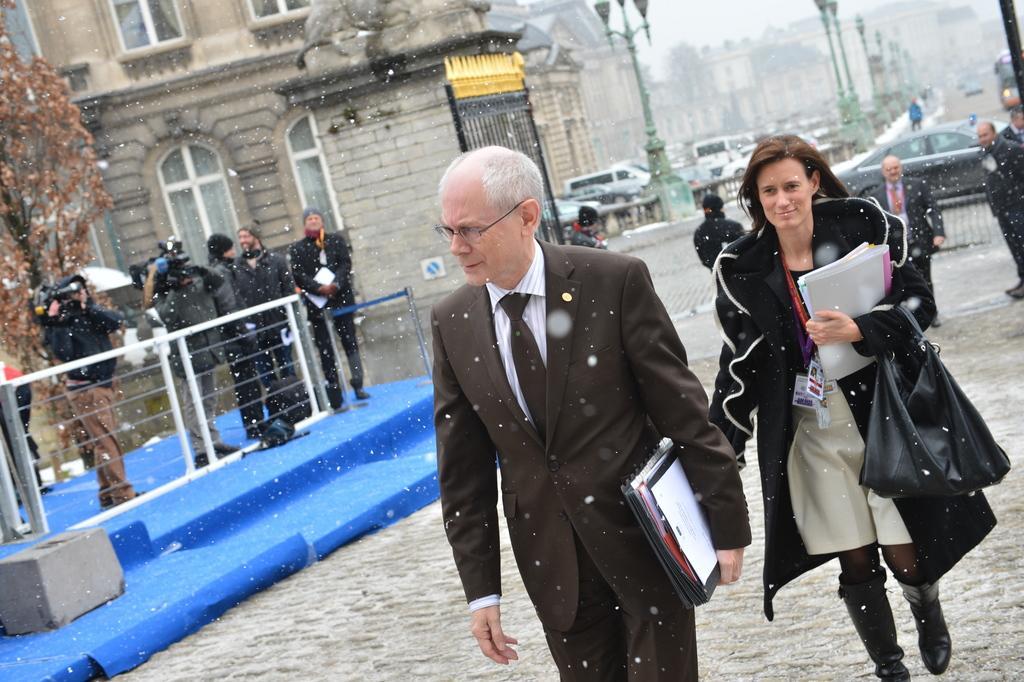Could you give a brief overview of what you see in this image? This picture describes about group of people, few are standing and few are walking, in the right side of the given image we can see a man and woman, they are holding papers in their hands, in the left side of the given image we can find few people are holding cameras, and also we can see few trees, poles, vehicles and buildings. 